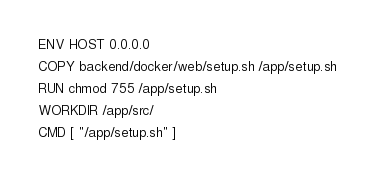<code> <loc_0><loc_0><loc_500><loc_500><_Dockerfile_>ENV HOST 0.0.0.0

COPY backend/docker/web/setup.sh /app/setup.sh

RUN chmod 755 /app/setup.sh

WORKDIR /app/src/

CMD [ "/app/setup.sh" ]
</code> 